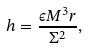<formula> <loc_0><loc_0><loc_500><loc_500>h = \frac { \epsilon M ^ { 3 } r } { \Sigma ^ { 2 } } ,</formula> 